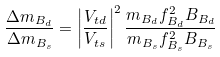<formula> <loc_0><loc_0><loc_500><loc_500>\frac { \Delta m _ { B _ { d } } } { { \Delta m _ { B _ { s } } } } = \left | \frac { V _ { t d } } { { V _ { t s } } } \right | ^ { 2 } \frac { m _ { B _ { d } } f ^ { 2 } _ { B _ { d } } B _ { B _ { d } } } { { m _ { B _ { s } } f ^ { 2 } _ { B _ { s } } B _ { B _ { s } } } }</formula> 